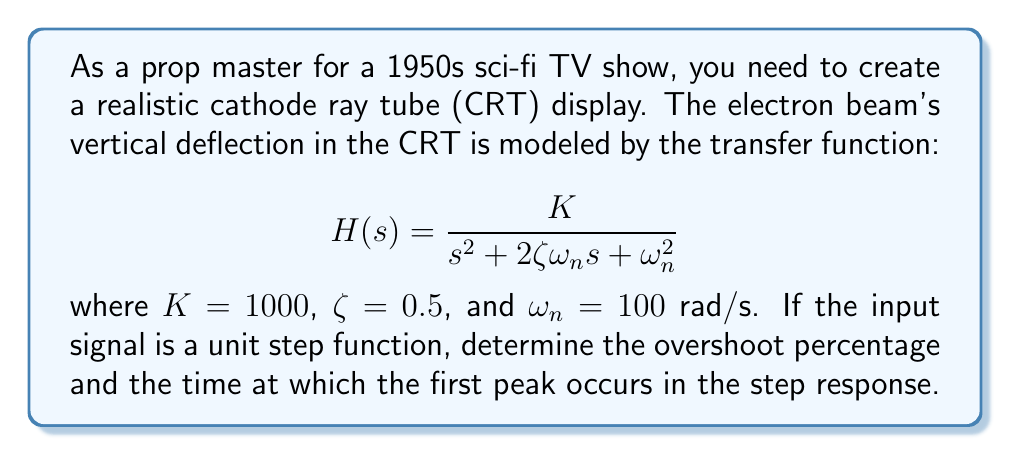What is the answer to this math problem? To analyze the time-domain behavior of the CRT display, we'll follow these steps:

1) The transfer function represents a second-order system. For a unit step input, the Laplace transform of the output is:

   $$Y(s) = H(s) \cdot \frac{1}{s} = \frac{K}{s(s^2 + 2\zeta\omega_n s + \omega_n^2)}$$

2) The inverse Laplace transform of this function gives the time-domain response:

   $$y(t) = K\left(1 - \frac{e^{-\zeta\omega_n t}}{\sqrt{1-\zeta^2}} \sin(\omega_d t + \phi)\right)$$

   where $\omega_d = \omega_n\sqrt{1-\zeta^2}$ and $\phi = \cos^{-1}(\zeta)$

3) The overshoot percentage is given by:

   $$OS\% = 100e^{-\zeta\pi/\sqrt{1-\zeta^2}}$$

4) Substituting $\zeta = 0.5$:

   $$OS\% = 100e^{-0.5\pi/\sqrt{1-0.5^2}} \approx 16.3\%$$

5) The time of the first peak (tp) is given by:

   $$t_p = \frac{\pi}{\omega_d} = \frac{\pi}{\omega_n\sqrt{1-\zeta^2}}$$

6) Substituting the values:

   $$t_p = \frac{\pi}{100\sqrt{1-0.5^2}} \approx 0.0363 \text{ seconds}$$

This analysis shows that the CRT display will have an initial overshoot followed by decaying oscillations, typical of older CRT monitors.
Answer: Overshoot percentage: 16.3%
Time of first peak: 0.0363 seconds 